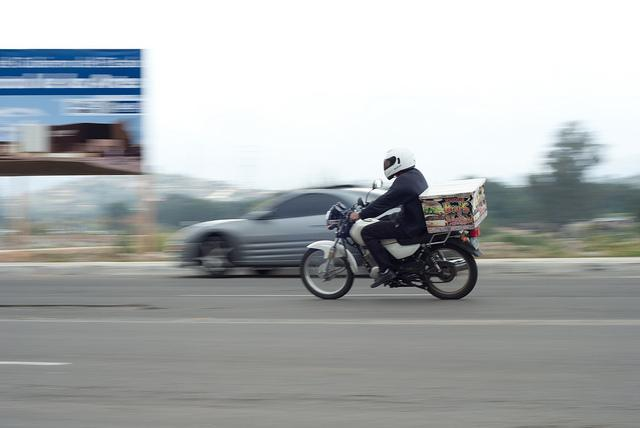How do motorcyclists carry gear? Please explain your reasoning. luggage space. The gear is for luggage. 